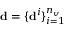<formula> <loc_0><loc_0><loc_500><loc_500>d = \{ d ^ { i } \} _ { i = 1 } ^ { n _ { v } }</formula> 